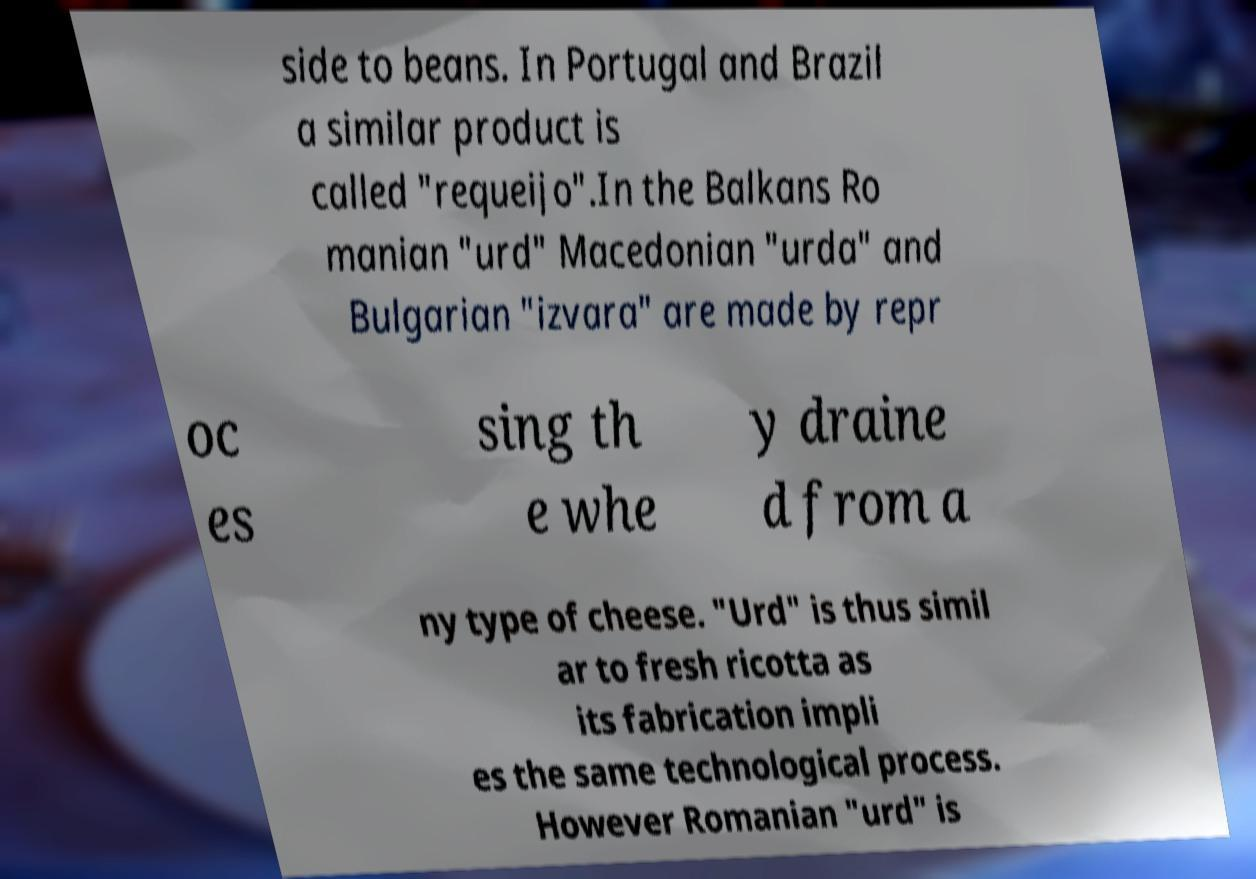Could you extract and type out the text from this image? side to beans. In Portugal and Brazil a similar product is called "requeijo".In the Balkans Ro manian "urd" Macedonian "urda" and Bulgarian "izvara" are made by repr oc es sing th e whe y draine d from a ny type of cheese. "Urd" is thus simil ar to fresh ricotta as its fabrication impli es the same technological process. However Romanian "urd" is 